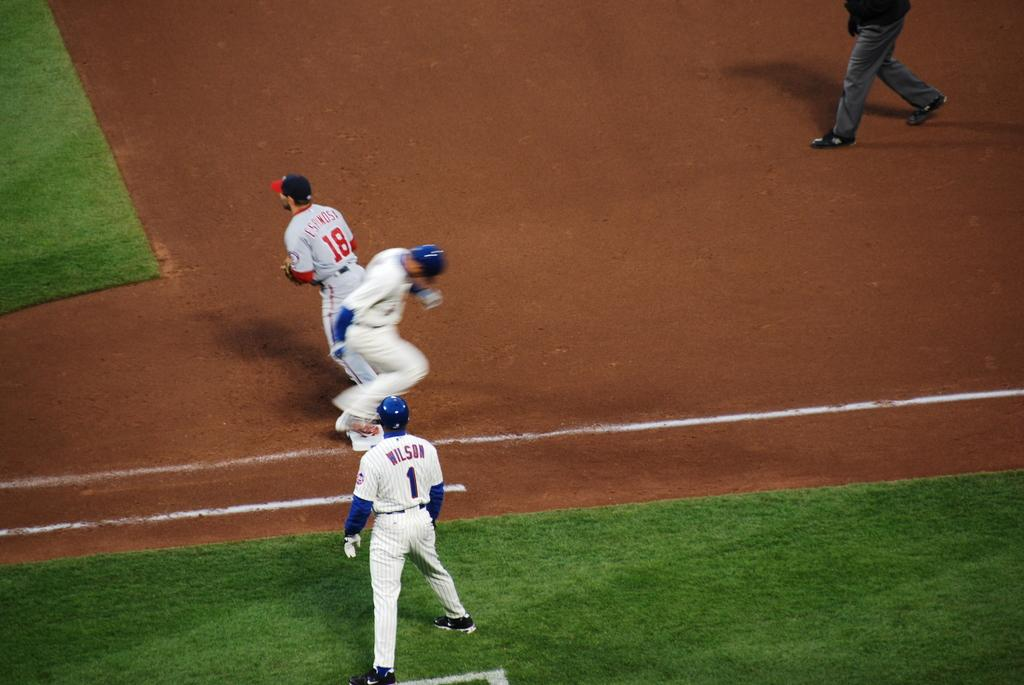<image>
Share a concise interpretation of the image provided. A man with Wilson on the back of his jersey is on a baseball field. 